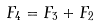<formula> <loc_0><loc_0><loc_500><loc_500>F _ { 4 } = F _ { 3 } + F _ { 2 }</formula> 